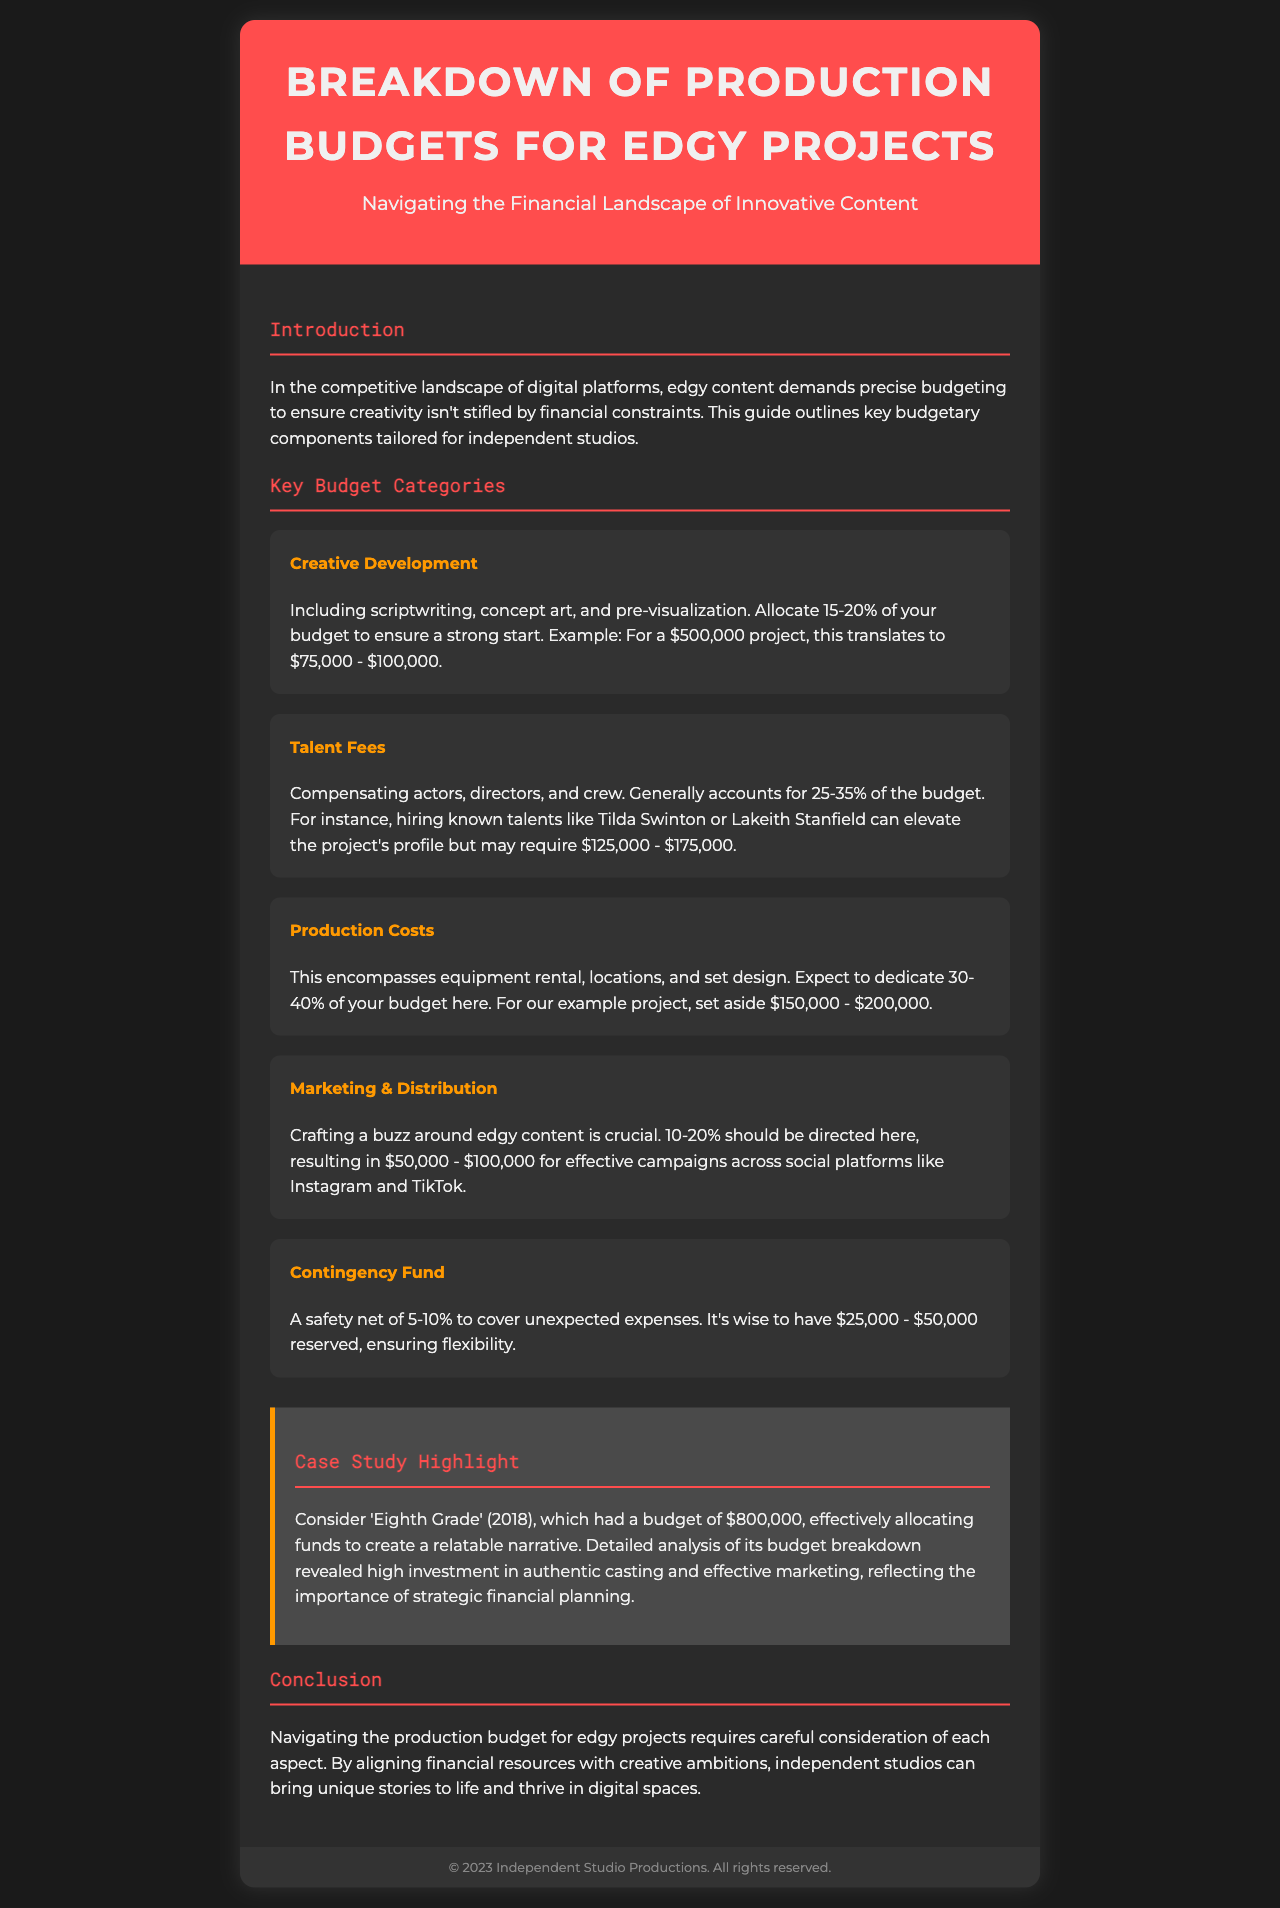What is the recommended percentage for Creative Development? The document states to allocate 15-20% of your budget for Creative Development.
Answer: 15-20% What is the budget range for Talent Fees in a $500,000 project? For a $500,000 project, Talent Fees generally account for $125,000 - $175,000.
Answer: $125,000 - $175,000 How much should be set aside for Production Costs? You should dedicate 30-40% of your budget, which translates to $150,000 - $200,000 in the example project.
Answer: $150,000 - $200,000 What is the purpose of the Contingency Fund? The Contingency Fund serves as a safety net to cover unexpected expenses.
Answer: Safety net What was the total budget for the case study 'Eighth Grade'? The document mentions that 'Eighth Grade' had a budget of $800,000.
Answer: $800,000 Which platforms are recommended for marketing campaigns? The document suggests promoting across social platforms like Instagram and TikTok.
Answer: Instagram and TikTok What is the topic of the brochure? The brochure covers the breakdown of production budgets for edgy projects.
Answer: Breakdown of Production Budgets for Edgy Projects How much of the budget should be directed to Marketing & Distribution? The document advises allocating 10-20% of the budget to Marketing & Distribution.
Answer: 10-20% What can effectively impact a project's profile according to the document? Hiring known talents like Tilda Swinton or Lakeith Stanfield can elevate the project's profile.
Answer: Known talents 